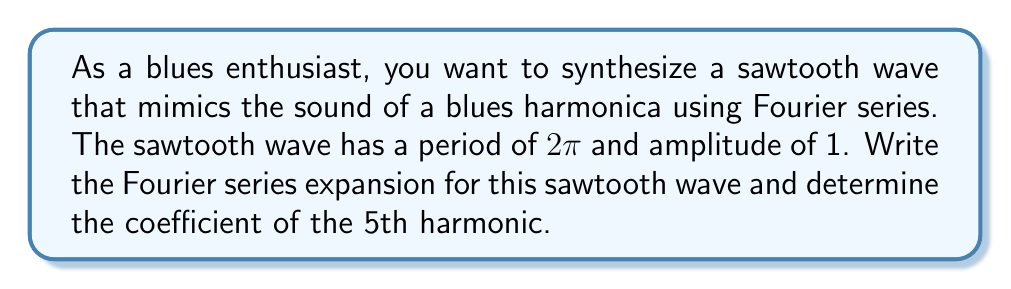What is the answer to this math problem? To synthesize a sawtooth wave using Fourier series, we follow these steps:

1) The general form of a sawtooth wave with period $2\pi$ and amplitude 1 is:

   $f(x) = -\frac{x}{\pi}$ for $-\pi < x < \pi$

2) The Fourier series expansion for a sawtooth wave is:

   $f(x) = -\frac{1}{2} - \sum_{n=1}^{\infty} \frac{1}{n\pi} \sin(nx)$

3) This can be rewritten as:

   $f(x) = -\frac{1}{2} - \frac{1}{\pi} [\sin(x) + \frac{1}{2}\sin(2x) + \frac{1}{3}\sin(3x) + \frac{1}{4}\sin(4x) + \frac{1}{5}\sin(5x) + ...]$

4) To find the coefficient of the 5th harmonic, we look at the term with $\sin(5x)$:

   $-\frac{1}{5\pi}\sin(5x)$

5) The coefficient is the number multiplying $\sin(5x)$, which is $-\frac{1}{5\pi}$.

This Fourier series representation allows us to synthesize a sawtooth wave by summing sine waves of different frequencies and amplitudes, similar to how a blues harmonica produces complex tones through its reeds.
Answer: The coefficient of the 5th harmonic in the Fourier series expansion of the sawtooth wave is $-\frac{1}{5\pi}$. 